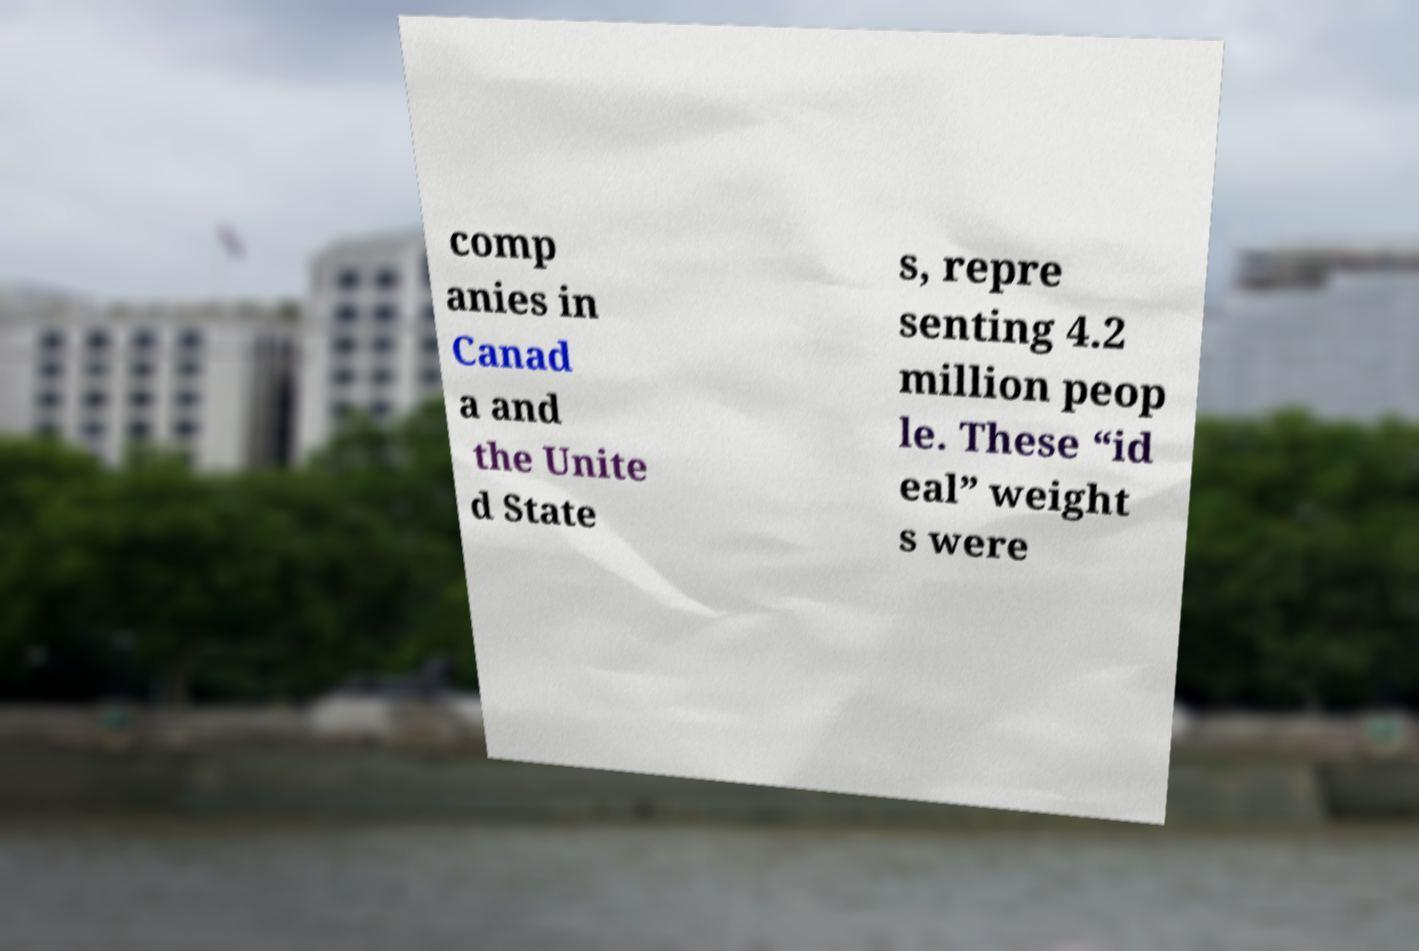Could you assist in decoding the text presented in this image and type it out clearly? comp anies in Canad a and the Unite d State s, repre senting 4.2 million peop le. These “id eal” weight s were 